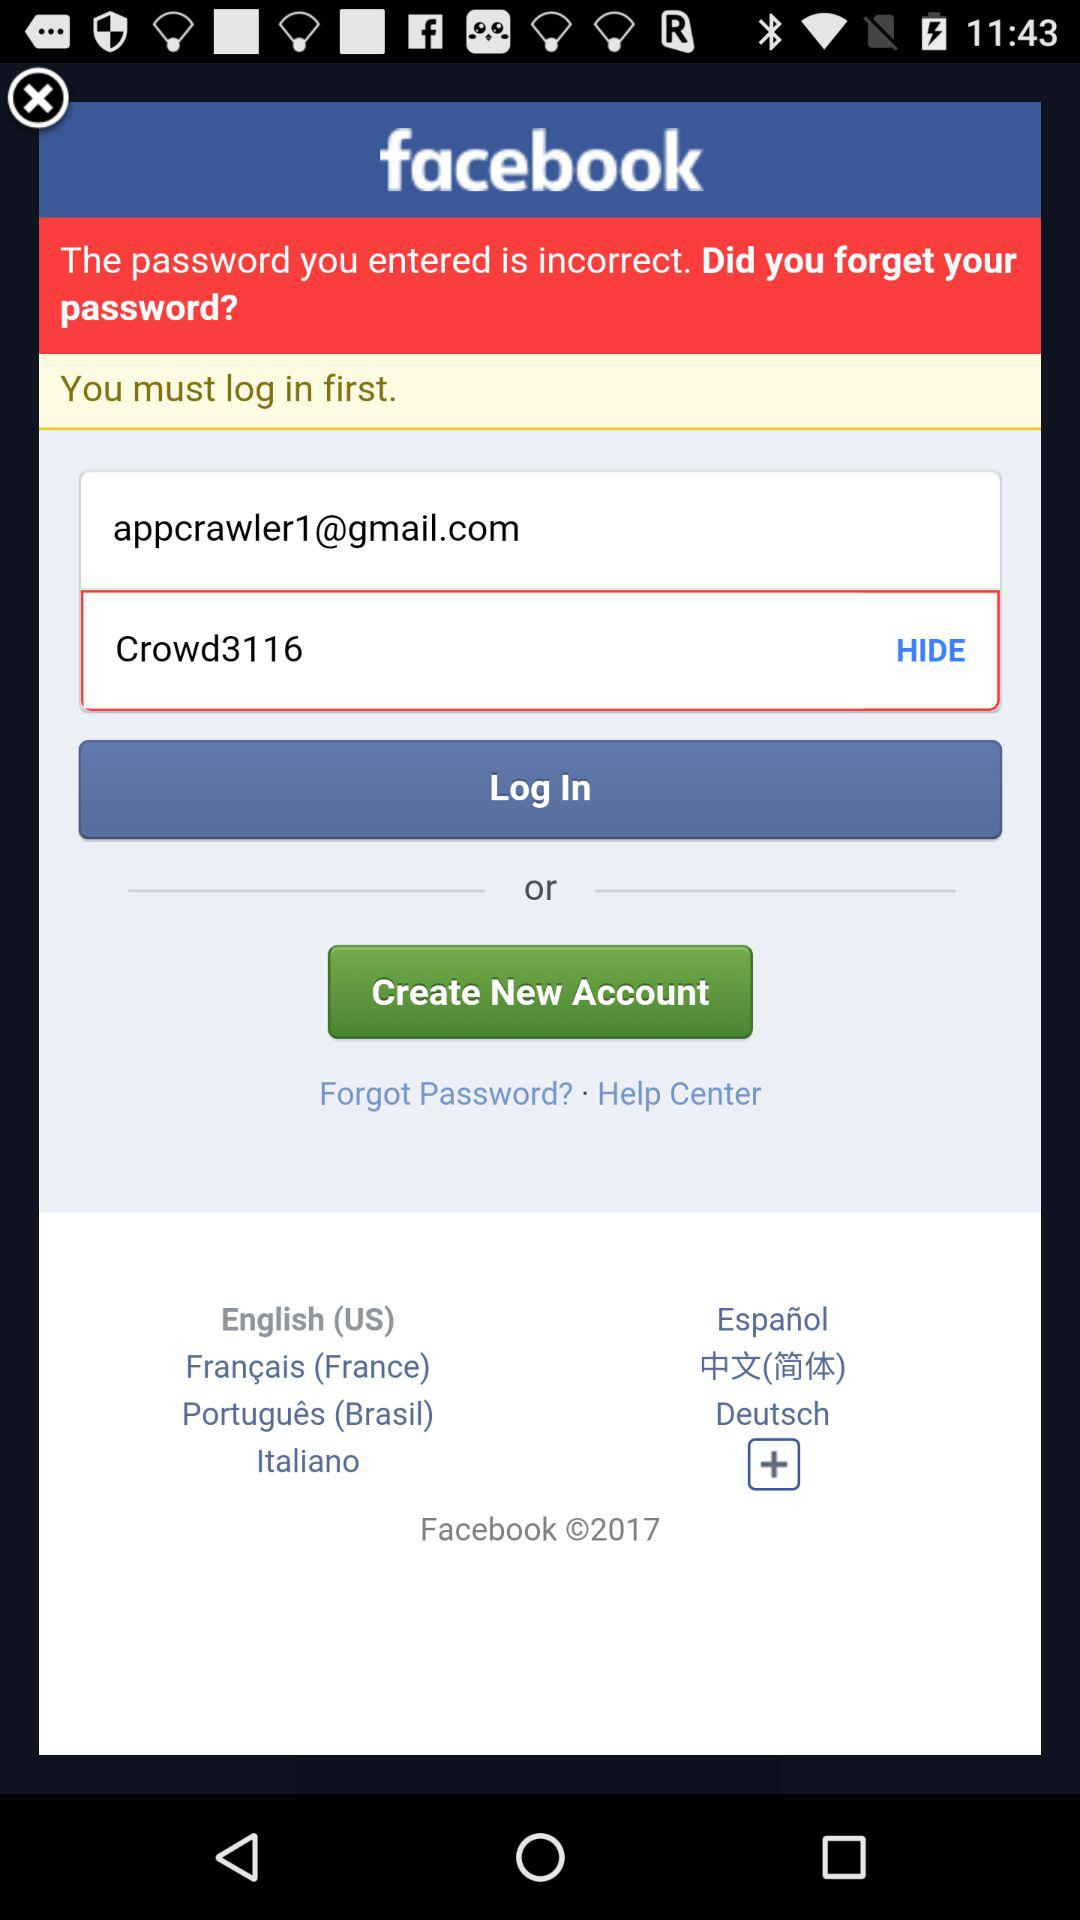What is the entered password? The entered password is "Crowd3116". 